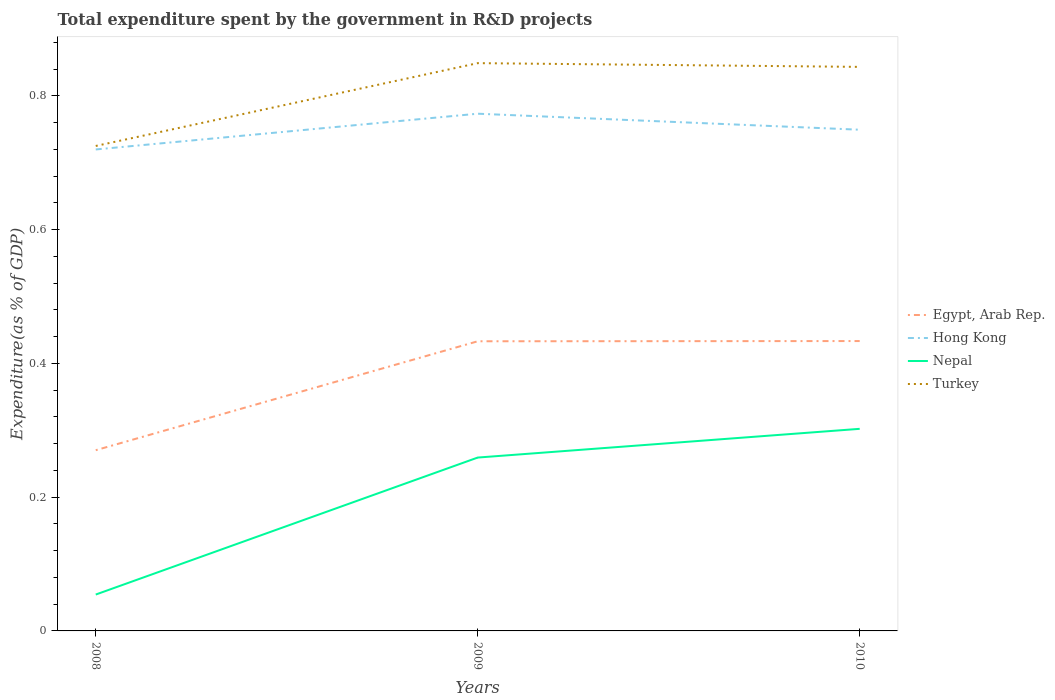Is the number of lines equal to the number of legend labels?
Provide a short and direct response. Yes. Across all years, what is the maximum total expenditure spent by the government in R&D projects in Nepal?
Offer a very short reply. 0.05. In which year was the total expenditure spent by the government in R&D projects in Nepal maximum?
Ensure brevity in your answer.  2008. What is the total total expenditure spent by the government in R&D projects in Hong Kong in the graph?
Offer a very short reply. -0.05. What is the difference between the highest and the second highest total expenditure spent by the government in R&D projects in Egypt, Arab Rep.?
Provide a short and direct response. 0.16. What is the difference between the highest and the lowest total expenditure spent by the government in R&D projects in Turkey?
Your response must be concise. 2. How many years are there in the graph?
Provide a succinct answer. 3. Are the values on the major ticks of Y-axis written in scientific E-notation?
Keep it short and to the point. No. Does the graph contain any zero values?
Your answer should be compact. No. Where does the legend appear in the graph?
Ensure brevity in your answer.  Center right. How are the legend labels stacked?
Your answer should be compact. Vertical. What is the title of the graph?
Provide a succinct answer. Total expenditure spent by the government in R&D projects. Does "United Arab Emirates" appear as one of the legend labels in the graph?
Your answer should be compact. No. What is the label or title of the Y-axis?
Keep it short and to the point. Expenditure(as % of GDP). What is the Expenditure(as % of GDP) of Egypt, Arab Rep. in 2008?
Offer a terse response. 0.27. What is the Expenditure(as % of GDP) of Hong Kong in 2008?
Make the answer very short. 0.72. What is the Expenditure(as % of GDP) in Nepal in 2008?
Offer a very short reply. 0.05. What is the Expenditure(as % of GDP) of Turkey in 2008?
Provide a short and direct response. 0.73. What is the Expenditure(as % of GDP) in Egypt, Arab Rep. in 2009?
Your answer should be compact. 0.43. What is the Expenditure(as % of GDP) of Hong Kong in 2009?
Provide a succinct answer. 0.77. What is the Expenditure(as % of GDP) of Nepal in 2009?
Your answer should be compact. 0.26. What is the Expenditure(as % of GDP) of Turkey in 2009?
Offer a terse response. 0.85. What is the Expenditure(as % of GDP) in Egypt, Arab Rep. in 2010?
Offer a very short reply. 0.43. What is the Expenditure(as % of GDP) of Hong Kong in 2010?
Make the answer very short. 0.75. What is the Expenditure(as % of GDP) of Nepal in 2010?
Provide a short and direct response. 0.3. What is the Expenditure(as % of GDP) in Turkey in 2010?
Make the answer very short. 0.84. Across all years, what is the maximum Expenditure(as % of GDP) of Egypt, Arab Rep.?
Keep it short and to the point. 0.43. Across all years, what is the maximum Expenditure(as % of GDP) in Hong Kong?
Provide a succinct answer. 0.77. Across all years, what is the maximum Expenditure(as % of GDP) of Nepal?
Offer a very short reply. 0.3. Across all years, what is the maximum Expenditure(as % of GDP) in Turkey?
Offer a very short reply. 0.85. Across all years, what is the minimum Expenditure(as % of GDP) of Egypt, Arab Rep.?
Offer a terse response. 0.27. Across all years, what is the minimum Expenditure(as % of GDP) of Hong Kong?
Offer a terse response. 0.72. Across all years, what is the minimum Expenditure(as % of GDP) of Nepal?
Give a very brief answer. 0.05. Across all years, what is the minimum Expenditure(as % of GDP) in Turkey?
Ensure brevity in your answer.  0.73. What is the total Expenditure(as % of GDP) in Egypt, Arab Rep. in the graph?
Ensure brevity in your answer.  1.14. What is the total Expenditure(as % of GDP) of Hong Kong in the graph?
Your answer should be compact. 2.24. What is the total Expenditure(as % of GDP) in Nepal in the graph?
Ensure brevity in your answer.  0.62. What is the total Expenditure(as % of GDP) of Turkey in the graph?
Keep it short and to the point. 2.42. What is the difference between the Expenditure(as % of GDP) of Egypt, Arab Rep. in 2008 and that in 2009?
Your response must be concise. -0.16. What is the difference between the Expenditure(as % of GDP) in Hong Kong in 2008 and that in 2009?
Make the answer very short. -0.05. What is the difference between the Expenditure(as % of GDP) in Nepal in 2008 and that in 2009?
Ensure brevity in your answer.  -0.2. What is the difference between the Expenditure(as % of GDP) in Turkey in 2008 and that in 2009?
Ensure brevity in your answer.  -0.12. What is the difference between the Expenditure(as % of GDP) in Egypt, Arab Rep. in 2008 and that in 2010?
Your answer should be very brief. -0.16. What is the difference between the Expenditure(as % of GDP) of Hong Kong in 2008 and that in 2010?
Give a very brief answer. -0.03. What is the difference between the Expenditure(as % of GDP) in Nepal in 2008 and that in 2010?
Offer a very short reply. -0.25. What is the difference between the Expenditure(as % of GDP) in Turkey in 2008 and that in 2010?
Ensure brevity in your answer.  -0.12. What is the difference between the Expenditure(as % of GDP) of Egypt, Arab Rep. in 2009 and that in 2010?
Provide a short and direct response. -0. What is the difference between the Expenditure(as % of GDP) of Hong Kong in 2009 and that in 2010?
Your answer should be compact. 0.02. What is the difference between the Expenditure(as % of GDP) of Nepal in 2009 and that in 2010?
Ensure brevity in your answer.  -0.04. What is the difference between the Expenditure(as % of GDP) of Turkey in 2009 and that in 2010?
Ensure brevity in your answer.  0.01. What is the difference between the Expenditure(as % of GDP) in Egypt, Arab Rep. in 2008 and the Expenditure(as % of GDP) in Hong Kong in 2009?
Your answer should be compact. -0.5. What is the difference between the Expenditure(as % of GDP) in Egypt, Arab Rep. in 2008 and the Expenditure(as % of GDP) in Nepal in 2009?
Your response must be concise. 0.01. What is the difference between the Expenditure(as % of GDP) of Egypt, Arab Rep. in 2008 and the Expenditure(as % of GDP) of Turkey in 2009?
Offer a very short reply. -0.58. What is the difference between the Expenditure(as % of GDP) of Hong Kong in 2008 and the Expenditure(as % of GDP) of Nepal in 2009?
Provide a short and direct response. 0.46. What is the difference between the Expenditure(as % of GDP) in Hong Kong in 2008 and the Expenditure(as % of GDP) in Turkey in 2009?
Give a very brief answer. -0.13. What is the difference between the Expenditure(as % of GDP) of Nepal in 2008 and the Expenditure(as % of GDP) of Turkey in 2009?
Offer a very short reply. -0.79. What is the difference between the Expenditure(as % of GDP) of Egypt, Arab Rep. in 2008 and the Expenditure(as % of GDP) of Hong Kong in 2010?
Your answer should be very brief. -0.48. What is the difference between the Expenditure(as % of GDP) of Egypt, Arab Rep. in 2008 and the Expenditure(as % of GDP) of Nepal in 2010?
Provide a short and direct response. -0.03. What is the difference between the Expenditure(as % of GDP) in Egypt, Arab Rep. in 2008 and the Expenditure(as % of GDP) in Turkey in 2010?
Make the answer very short. -0.57. What is the difference between the Expenditure(as % of GDP) in Hong Kong in 2008 and the Expenditure(as % of GDP) in Nepal in 2010?
Make the answer very short. 0.42. What is the difference between the Expenditure(as % of GDP) of Hong Kong in 2008 and the Expenditure(as % of GDP) of Turkey in 2010?
Provide a short and direct response. -0.12. What is the difference between the Expenditure(as % of GDP) of Nepal in 2008 and the Expenditure(as % of GDP) of Turkey in 2010?
Your response must be concise. -0.79. What is the difference between the Expenditure(as % of GDP) in Egypt, Arab Rep. in 2009 and the Expenditure(as % of GDP) in Hong Kong in 2010?
Keep it short and to the point. -0.32. What is the difference between the Expenditure(as % of GDP) in Egypt, Arab Rep. in 2009 and the Expenditure(as % of GDP) in Nepal in 2010?
Your answer should be compact. 0.13. What is the difference between the Expenditure(as % of GDP) of Egypt, Arab Rep. in 2009 and the Expenditure(as % of GDP) of Turkey in 2010?
Your response must be concise. -0.41. What is the difference between the Expenditure(as % of GDP) of Hong Kong in 2009 and the Expenditure(as % of GDP) of Nepal in 2010?
Offer a terse response. 0.47. What is the difference between the Expenditure(as % of GDP) in Hong Kong in 2009 and the Expenditure(as % of GDP) in Turkey in 2010?
Make the answer very short. -0.07. What is the difference between the Expenditure(as % of GDP) in Nepal in 2009 and the Expenditure(as % of GDP) in Turkey in 2010?
Give a very brief answer. -0.58. What is the average Expenditure(as % of GDP) in Egypt, Arab Rep. per year?
Your answer should be compact. 0.38. What is the average Expenditure(as % of GDP) in Hong Kong per year?
Provide a short and direct response. 0.75. What is the average Expenditure(as % of GDP) of Nepal per year?
Ensure brevity in your answer.  0.21. What is the average Expenditure(as % of GDP) in Turkey per year?
Give a very brief answer. 0.81. In the year 2008, what is the difference between the Expenditure(as % of GDP) of Egypt, Arab Rep. and Expenditure(as % of GDP) of Hong Kong?
Give a very brief answer. -0.45. In the year 2008, what is the difference between the Expenditure(as % of GDP) of Egypt, Arab Rep. and Expenditure(as % of GDP) of Nepal?
Your answer should be very brief. 0.22. In the year 2008, what is the difference between the Expenditure(as % of GDP) of Egypt, Arab Rep. and Expenditure(as % of GDP) of Turkey?
Your answer should be very brief. -0.45. In the year 2008, what is the difference between the Expenditure(as % of GDP) of Hong Kong and Expenditure(as % of GDP) of Nepal?
Ensure brevity in your answer.  0.67. In the year 2008, what is the difference between the Expenditure(as % of GDP) in Hong Kong and Expenditure(as % of GDP) in Turkey?
Offer a terse response. -0.01. In the year 2008, what is the difference between the Expenditure(as % of GDP) of Nepal and Expenditure(as % of GDP) of Turkey?
Keep it short and to the point. -0.67. In the year 2009, what is the difference between the Expenditure(as % of GDP) in Egypt, Arab Rep. and Expenditure(as % of GDP) in Hong Kong?
Keep it short and to the point. -0.34. In the year 2009, what is the difference between the Expenditure(as % of GDP) in Egypt, Arab Rep. and Expenditure(as % of GDP) in Nepal?
Offer a terse response. 0.17. In the year 2009, what is the difference between the Expenditure(as % of GDP) of Egypt, Arab Rep. and Expenditure(as % of GDP) of Turkey?
Offer a terse response. -0.42. In the year 2009, what is the difference between the Expenditure(as % of GDP) in Hong Kong and Expenditure(as % of GDP) in Nepal?
Offer a very short reply. 0.51. In the year 2009, what is the difference between the Expenditure(as % of GDP) in Hong Kong and Expenditure(as % of GDP) in Turkey?
Ensure brevity in your answer.  -0.08. In the year 2009, what is the difference between the Expenditure(as % of GDP) in Nepal and Expenditure(as % of GDP) in Turkey?
Give a very brief answer. -0.59. In the year 2010, what is the difference between the Expenditure(as % of GDP) of Egypt, Arab Rep. and Expenditure(as % of GDP) of Hong Kong?
Your answer should be very brief. -0.32. In the year 2010, what is the difference between the Expenditure(as % of GDP) of Egypt, Arab Rep. and Expenditure(as % of GDP) of Nepal?
Keep it short and to the point. 0.13. In the year 2010, what is the difference between the Expenditure(as % of GDP) in Egypt, Arab Rep. and Expenditure(as % of GDP) in Turkey?
Offer a terse response. -0.41. In the year 2010, what is the difference between the Expenditure(as % of GDP) of Hong Kong and Expenditure(as % of GDP) of Nepal?
Give a very brief answer. 0.45. In the year 2010, what is the difference between the Expenditure(as % of GDP) of Hong Kong and Expenditure(as % of GDP) of Turkey?
Your answer should be very brief. -0.09. In the year 2010, what is the difference between the Expenditure(as % of GDP) in Nepal and Expenditure(as % of GDP) in Turkey?
Offer a very short reply. -0.54. What is the ratio of the Expenditure(as % of GDP) of Egypt, Arab Rep. in 2008 to that in 2009?
Offer a terse response. 0.62. What is the ratio of the Expenditure(as % of GDP) of Hong Kong in 2008 to that in 2009?
Your answer should be compact. 0.93. What is the ratio of the Expenditure(as % of GDP) of Nepal in 2008 to that in 2009?
Ensure brevity in your answer.  0.21. What is the ratio of the Expenditure(as % of GDP) of Turkey in 2008 to that in 2009?
Your answer should be very brief. 0.85. What is the ratio of the Expenditure(as % of GDP) in Egypt, Arab Rep. in 2008 to that in 2010?
Your answer should be compact. 0.62. What is the ratio of the Expenditure(as % of GDP) of Hong Kong in 2008 to that in 2010?
Offer a terse response. 0.96. What is the ratio of the Expenditure(as % of GDP) of Nepal in 2008 to that in 2010?
Offer a terse response. 0.18. What is the ratio of the Expenditure(as % of GDP) of Turkey in 2008 to that in 2010?
Give a very brief answer. 0.86. What is the ratio of the Expenditure(as % of GDP) of Egypt, Arab Rep. in 2009 to that in 2010?
Your answer should be compact. 1. What is the ratio of the Expenditure(as % of GDP) in Hong Kong in 2009 to that in 2010?
Give a very brief answer. 1.03. What is the ratio of the Expenditure(as % of GDP) in Nepal in 2009 to that in 2010?
Your response must be concise. 0.86. What is the ratio of the Expenditure(as % of GDP) in Turkey in 2009 to that in 2010?
Give a very brief answer. 1.01. What is the difference between the highest and the second highest Expenditure(as % of GDP) in Hong Kong?
Make the answer very short. 0.02. What is the difference between the highest and the second highest Expenditure(as % of GDP) of Nepal?
Provide a succinct answer. 0.04. What is the difference between the highest and the second highest Expenditure(as % of GDP) in Turkey?
Provide a succinct answer. 0.01. What is the difference between the highest and the lowest Expenditure(as % of GDP) of Egypt, Arab Rep.?
Provide a short and direct response. 0.16. What is the difference between the highest and the lowest Expenditure(as % of GDP) in Hong Kong?
Offer a very short reply. 0.05. What is the difference between the highest and the lowest Expenditure(as % of GDP) of Nepal?
Your answer should be compact. 0.25. What is the difference between the highest and the lowest Expenditure(as % of GDP) in Turkey?
Your answer should be compact. 0.12. 